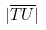Convert formula to latex. <formula><loc_0><loc_0><loc_500><loc_500>| \overline { T U } |</formula> 